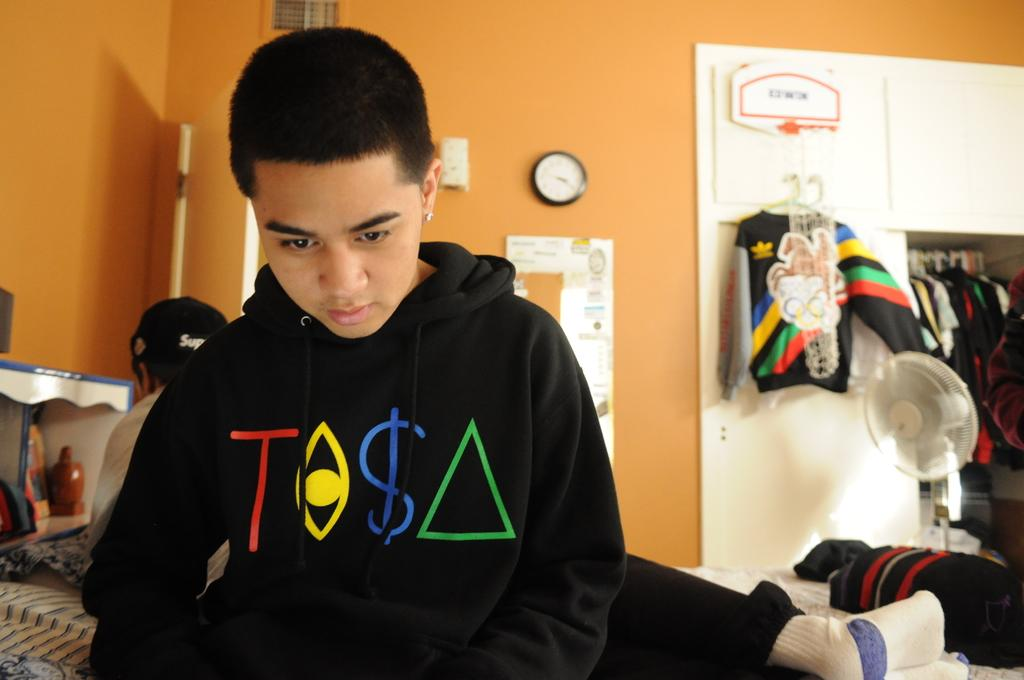<image>
Render a clear and concise summary of the photo. boy in bedroom wearing black sweatshirt that has a red T and blue $ on it 